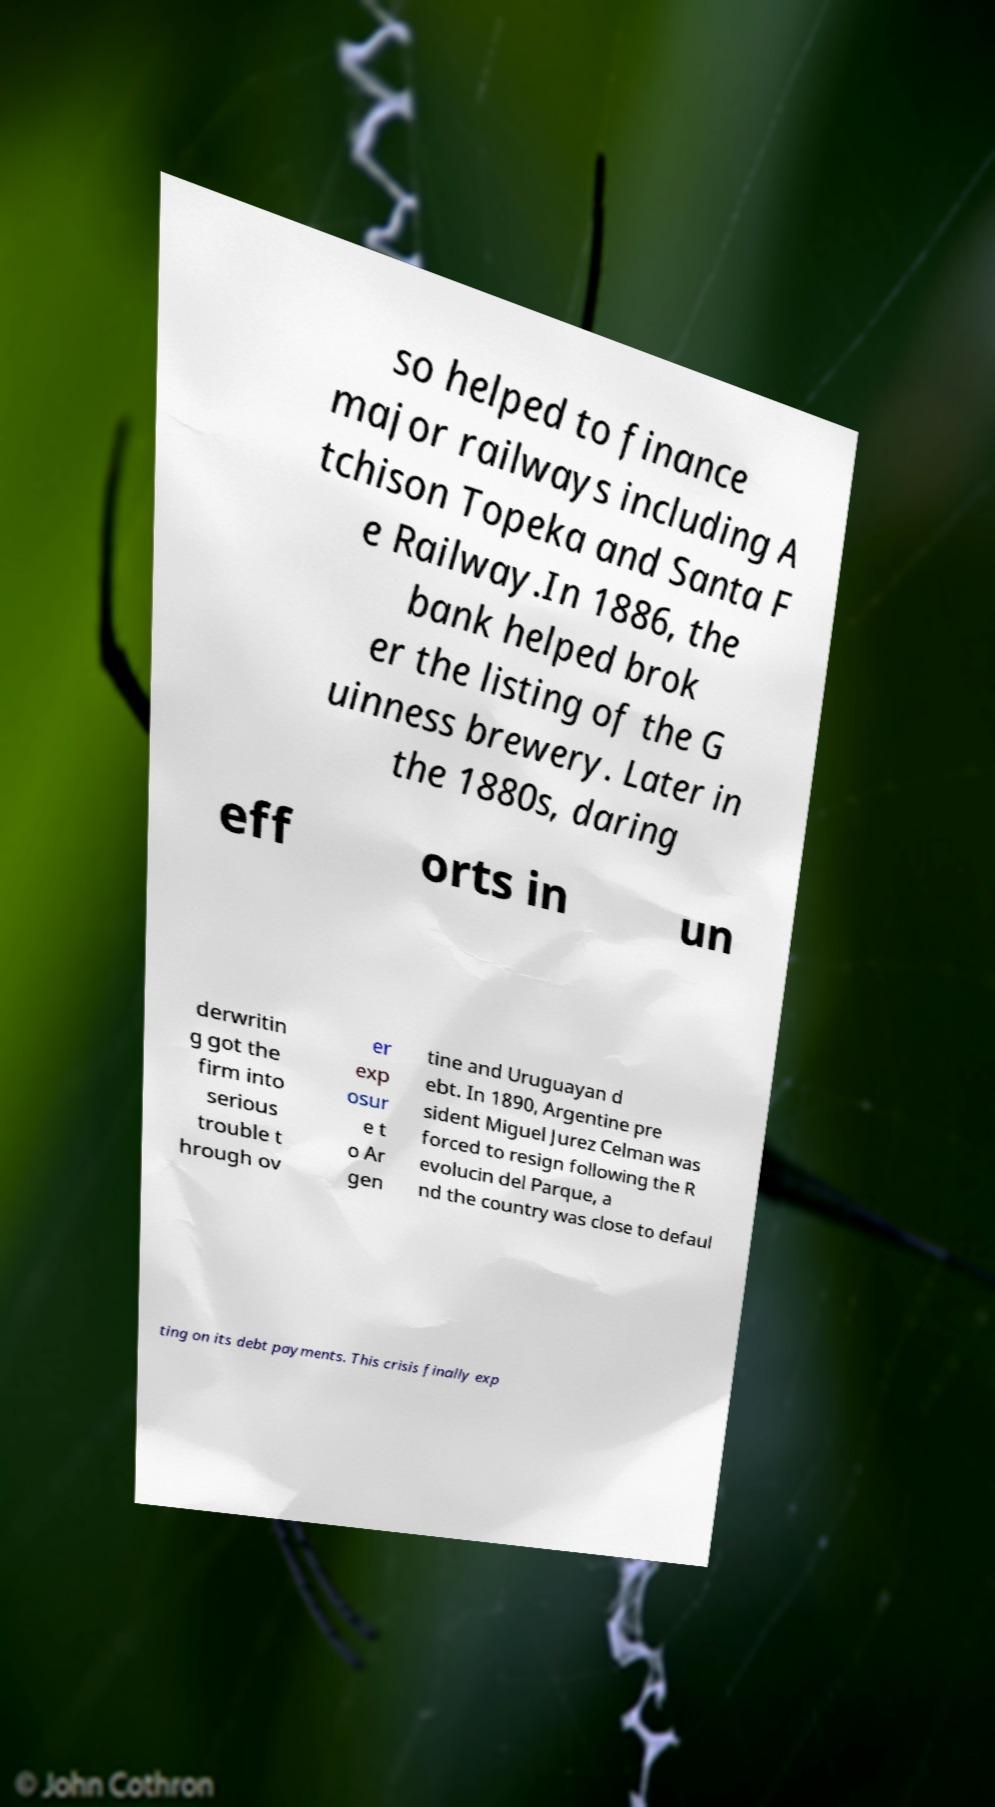Please read and relay the text visible in this image. What does it say? so helped to finance major railways including A tchison Topeka and Santa F e Railway.In 1886, the bank helped brok er the listing of the G uinness brewery. Later in the 1880s, daring eff orts in un derwritin g got the firm into serious trouble t hrough ov er exp osur e t o Ar gen tine and Uruguayan d ebt. In 1890, Argentine pre sident Miguel Jurez Celman was forced to resign following the R evolucin del Parque, a nd the country was close to defaul ting on its debt payments. This crisis finally exp 